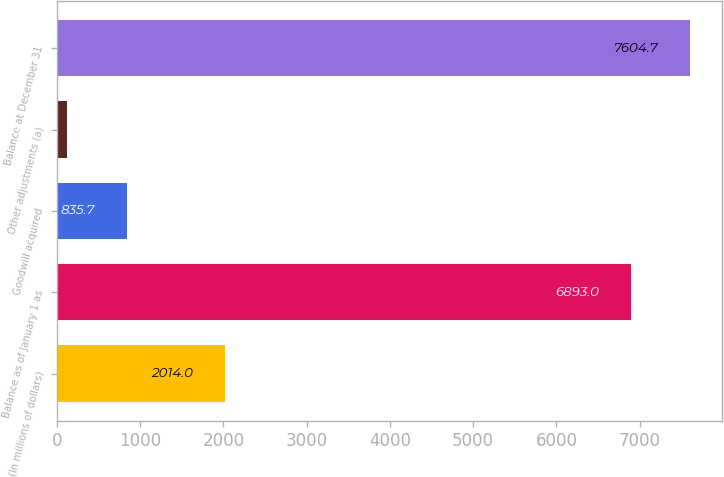Convert chart. <chart><loc_0><loc_0><loc_500><loc_500><bar_chart><fcel>(In millions of dollars)<fcel>Balance as of January 1 as<fcel>Goodwill acquired<fcel>Other adjustments (a)<fcel>Balance at December 31<nl><fcel>2014<fcel>6893<fcel>835.7<fcel>124<fcel>7604.7<nl></chart> 